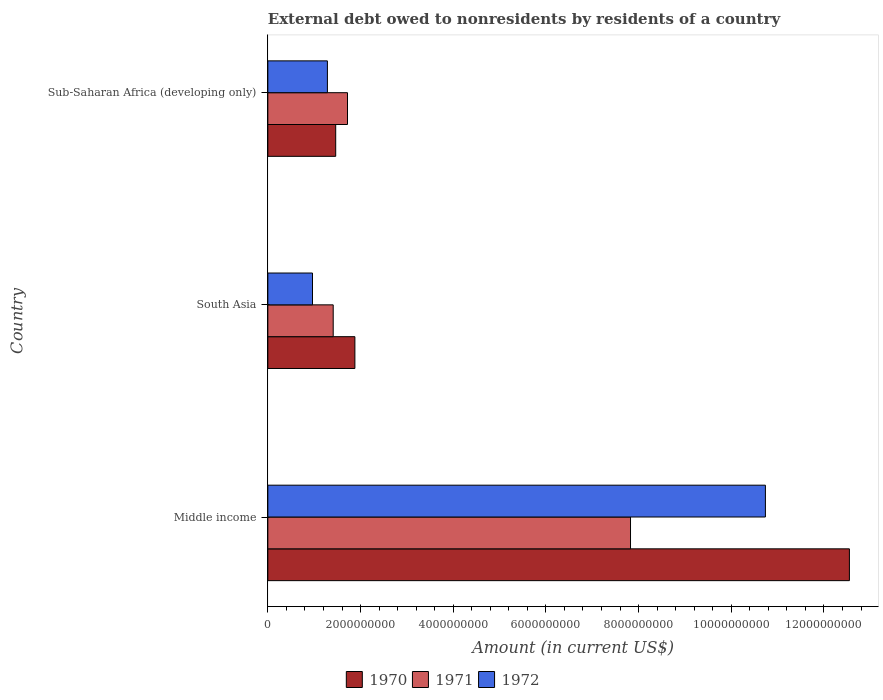How many groups of bars are there?
Your response must be concise. 3. Are the number of bars on each tick of the Y-axis equal?
Give a very brief answer. Yes. What is the label of the 2nd group of bars from the top?
Keep it short and to the point. South Asia. In how many cases, is the number of bars for a given country not equal to the number of legend labels?
Ensure brevity in your answer.  0. What is the external debt owed by residents in 1970 in South Asia?
Provide a short and direct response. 1.88e+09. Across all countries, what is the maximum external debt owed by residents in 1970?
Your response must be concise. 1.25e+1. Across all countries, what is the minimum external debt owed by residents in 1972?
Offer a terse response. 9.64e+08. In which country was the external debt owed by residents in 1971 maximum?
Provide a short and direct response. Middle income. In which country was the external debt owed by residents in 1971 minimum?
Provide a succinct answer. South Asia. What is the total external debt owed by residents in 1972 in the graph?
Your response must be concise. 1.30e+1. What is the difference between the external debt owed by residents in 1972 in Middle income and that in Sub-Saharan Africa (developing only)?
Your answer should be very brief. 9.45e+09. What is the difference between the external debt owed by residents in 1971 in Middle income and the external debt owed by residents in 1970 in Sub-Saharan Africa (developing only)?
Offer a very short reply. 6.36e+09. What is the average external debt owed by residents in 1971 per country?
Provide a short and direct response. 3.65e+09. What is the difference between the external debt owed by residents in 1972 and external debt owed by residents in 1970 in Sub-Saharan Africa (developing only)?
Ensure brevity in your answer.  -1.79e+08. In how many countries, is the external debt owed by residents in 1970 greater than 3200000000 US$?
Provide a succinct answer. 1. What is the ratio of the external debt owed by residents in 1970 in South Asia to that in Sub-Saharan Africa (developing only)?
Make the answer very short. 1.28. Is the external debt owed by residents in 1971 in South Asia less than that in Sub-Saharan Africa (developing only)?
Your answer should be very brief. Yes. Is the difference between the external debt owed by residents in 1972 in Middle income and Sub-Saharan Africa (developing only) greater than the difference between the external debt owed by residents in 1970 in Middle income and Sub-Saharan Africa (developing only)?
Keep it short and to the point. No. What is the difference between the highest and the second highest external debt owed by residents in 1972?
Ensure brevity in your answer.  9.45e+09. What is the difference between the highest and the lowest external debt owed by residents in 1970?
Give a very brief answer. 1.11e+1. In how many countries, is the external debt owed by residents in 1971 greater than the average external debt owed by residents in 1971 taken over all countries?
Offer a very short reply. 1. What does the 3rd bar from the top in Sub-Saharan Africa (developing only) represents?
Give a very brief answer. 1970. How many bars are there?
Keep it short and to the point. 9. How many countries are there in the graph?
Your response must be concise. 3. What is the difference between two consecutive major ticks on the X-axis?
Your answer should be compact. 2.00e+09. Are the values on the major ticks of X-axis written in scientific E-notation?
Offer a terse response. No. Does the graph contain grids?
Keep it short and to the point. No. What is the title of the graph?
Make the answer very short. External debt owed to nonresidents by residents of a country. What is the label or title of the Y-axis?
Your answer should be compact. Country. What is the Amount (in current US$) of 1970 in Middle income?
Give a very brief answer. 1.25e+1. What is the Amount (in current US$) in 1971 in Middle income?
Your response must be concise. 7.83e+09. What is the Amount (in current US$) of 1972 in Middle income?
Give a very brief answer. 1.07e+1. What is the Amount (in current US$) in 1970 in South Asia?
Your response must be concise. 1.88e+09. What is the Amount (in current US$) in 1971 in South Asia?
Offer a terse response. 1.41e+09. What is the Amount (in current US$) of 1972 in South Asia?
Provide a short and direct response. 9.64e+08. What is the Amount (in current US$) of 1970 in Sub-Saharan Africa (developing only)?
Provide a short and direct response. 1.46e+09. What is the Amount (in current US$) in 1971 in Sub-Saharan Africa (developing only)?
Make the answer very short. 1.72e+09. What is the Amount (in current US$) of 1972 in Sub-Saharan Africa (developing only)?
Make the answer very short. 1.29e+09. Across all countries, what is the maximum Amount (in current US$) in 1970?
Give a very brief answer. 1.25e+1. Across all countries, what is the maximum Amount (in current US$) of 1971?
Provide a short and direct response. 7.83e+09. Across all countries, what is the maximum Amount (in current US$) in 1972?
Your answer should be very brief. 1.07e+1. Across all countries, what is the minimum Amount (in current US$) of 1970?
Provide a succinct answer. 1.46e+09. Across all countries, what is the minimum Amount (in current US$) of 1971?
Make the answer very short. 1.41e+09. Across all countries, what is the minimum Amount (in current US$) in 1972?
Offer a terse response. 9.64e+08. What is the total Amount (in current US$) in 1970 in the graph?
Your answer should be compact. 1.59e+1. What is the total Amount (in current US$) in 1971 in the graph?
Your answer should be compact. 1.10e+1. What is the total Amount (in current US$) in 1972 in the graph?
Offer a very short reply. 1.30e+1. What is the difference between the Amount (in current US$) of 1970 in Middle income and that in South Asia?
Keep it short and to the point. 1.07e+1. What is the difference between the Amount (in current US$) of 1971 in Middle income and that in South Asia?
Ensure brevity in your answer.  6.42e+09. What is the difference between the Amount (in current US$) of 1972 in Middle income and that in South Asia?
Make the answer very short. 9.77e+09. What is the difference between the Amount (in current US$) in 1970 in Middle income and that in Sub-Saharan Africa (developing only)?
Provide a succinct answer. 1.11e+1. What is the difference between the Amount (in current US$) of 1971 in Middle income and that in Sub-Saharan Africa (developing only)?
Provide a succinct answer. 6.11e+09. What is the difference between the Amount (in current US$) in 1972 in Middle income and that in Sub-Saharan Africa (developing only)?
Make the answer very short. 9.45e+09. What is the difference between the Amount (in current US$) of 1970 in South Asia and that in Sub-Saharan Africa (developing only)?
Make the answer very short. 4.14e+08. What is the difference between the Amount (in current US$) of 1971 in South Asia and that in Sub-Saharan Africa (developing only)?
Your answer should be very brief. -3.08e+08. What is the difference between the Amount (in current US$) of 1972 in South Asia and that in Sub-Saharan Africa (developing only)?
Provide a short and direct response. -3.22e+08. What is the difference between the Amount (in current US$) in 1970 in Middle income and the Amount (in current US$) in 1971 in South Asia?
Keep it short and to the point. 1.11e+1. What is the difference between the Amount (in current US$) in 1970 in Middle income and the Amount (in current US$) in 1972 in South Asia?
Your response must be concise. 1.16e+1. What is the difference between the Amount (in current US$) in 1971 in Middle income and the Amount (in current US$) in 1972 in South Asia?
Your answer should be compact. 6.86e+09. What is the difference between the Amount (in current US$) in 1970 in Middle income and the Amount (in current US$) in 1971 in Sub-Saharan Africa (developing only)?
Give a very brief answer. 1.08e+1. What is the difference between the Amount (in current US$) in 1970 in Middle income and the Amount (in current US$) in 1972 in Sub-Saharan Africa (developing only)?
Provide a short and direct response. 1.13e+1. What is the difference between the Amount (in current US$) of 1971 in Middle income and the Amount (in current US$) of 1972 in Sub-Saharan Africa (developing only)?
Keep it short and to the point. 6.54e+09. What is the difference between the Amount (in current US$) in 1970 in South Asia and the Amount (in current US$) in 1971 in Sub-Saharan Africa (developing only)?
Offer a very short reply. 1.60e+08. What is the difference between the Amount (in current US$) in 1970 in South Asia and the Amount (in current US$) in 1972 in Sub-Saharan Africa (developing only)?
Provide a short and direct response. 5.93e+08. What is the difference between the Amount (in current US$) of 1971 in South Asia and the Amount (in current US$) of 1972 in Sub-Saharan Africa (developing only)?
Make the answer very short. 1.25e+08. What is the average Amount (in current US$) of 1970 per country?
Offer a terse response. 5.30e+09. What is the average Amount (in current US$) in 1971 per country?
Provide a short and direct response. 3.65e+09. What is the average Amount (in current US$) of 1972 per country?
Keep it short and to the point. 4.33e+09. What is the difference between the Amount (in current US$) in 1970 and Amount (in current US$) in 1971 in Middle income?
Offer a terse response. 4.72e+09. What is the difference between the Amount (in current US$) in 1970 and Amount (in current US$) in 1972 in Middle income?
Your response must be concise. 1.81e+09. What is the difference between the Amount (in current US$) in 1971 and Amount (in current US$) in 1972 in Middle income?
Provide a short and direct response. -2.91e+09. What is the difference between the Amount (in current US$) of 1970 and Amount (in current US$) of 1971 in South Asia?
Offer a very short reply. 4.68e+08. What is the difference between the Amount (in current US$) of 1970 and Amount (in current US$) of 1972 in South Asia?
Keep it short and to the point. 9.15e+08. What is the difference between the Amount (in current US$) of 1971 and Amount (in current US$) of 1972 in South Asia?
Your response must be concise. 4.47e+08. What is the difference between the Amount (in current US$) of 1970 and Amount (in current US$) of 1971 in Sub-Saharan Africa (developing only)?
Your response must be concise. -2.55e+08. What is the difference between the Amount (in current US$) in 1970 and Amount (in current US$) in 1972 in Sub-Saharan Africa (developing only)?
Offer a terse response. 1.79e+08. What is the difference between the Amount (in current US$) in 1971 and Amount (in current US$) in 1972 in Sub-Saharan Africa (developing only)?
Offer a terse response. 4.33e+08. What is the ratio of the Amount (in current US$) of 1970 in Middle income to that in South Asia?
Offer a very short reply. 6.68. What is the ratio of the Amount (in current US$) in 1971 in Middle income to that in South Asia?
Your response must be concise. 5.55. What is the ratio of the Amount (in current US$) in 1972 in Middle income to that in South Asia?
Your answer should be very brief. 11.14. What is the ratio of the Amount (in current US$) in 1970 in Middle income to that in Sub-Saharan Africa (developing only)?
Keep it short and to the point. 8.57. What is the ratio of the Amount (in current US$) of 1971 in Middle income to that in Sub-Saharan Africa (developing only)?
Keep it short and to the point. 4.55. What is the ratio of the Amount (in current US$) of 1972 in Middle income to that in Sub-Saharan Africa (developing only)?
Offer a terse response. 8.35. What is the ratio of the Amount (in current US$) of 1970 in South Asia to that in Sub-Saharan Africa (developing only)?
Offer a terse response. 1.28. What is the ratio of the Amount (in current US$) in 1971 in South Asia to that in Sub-Saharan Africa (developing only)?
Provide a succinct answer. 0.82. What is the ratio of the Amount (in current US$) of 1972 in South Asia to that in Sub-Saharan Africa (developing only)?
Provide a succinct answer. 0.75. What is the difference between the highest and the second highest Amount (in current US$) in 1970?
Ensure brevity in your answer.  1.07e+1. What is the difference between the highest and the second highest Amount (in current US$) of 1971?
Give a very brief answer. 6.11e+09. What is the difference between the highest and the second highest Amount (in current US$) of 1972?
Your response must be concise. 9.45e+09. What is the difference between the highest and the lowest Amount (in current US$) in 1970?
Keep it short and to the point. 1.11e+1. What is the difference between the highest and the lowest Amount (in current US$) of 1971?
Keep it short and to the point. 6.42e+09. What is the difference between the highest and the lowest Amount (in current US$) in 1972?
Your answer should be compact. 9.77e+09. 